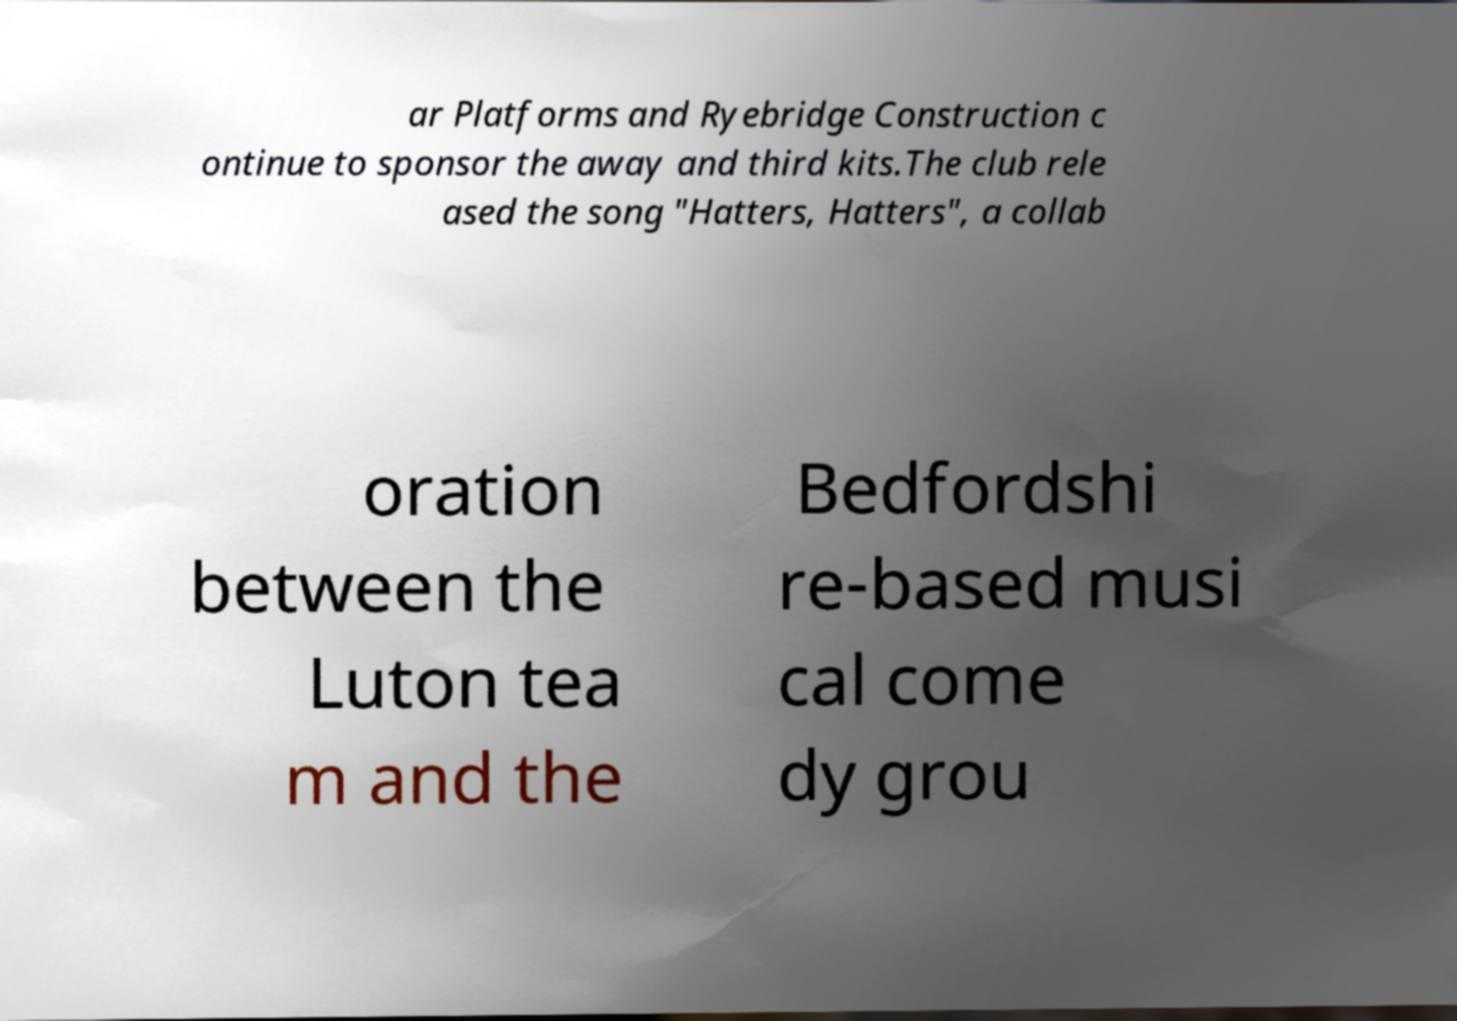Please identify and transcribe the text found in this image. ar Platforms and Ryebridge Construction c ontinue to sponsor the away and third kits.The club rele ased the song "Hatters, Hatters", a collab oration between the Luton tea m and the Bedfordshi re-based musi cal come dy grou 